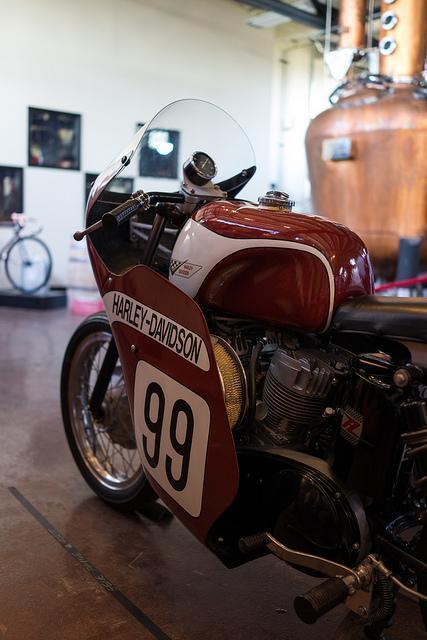How many motorcycles can you see?
Give a very brief answer. 1. 